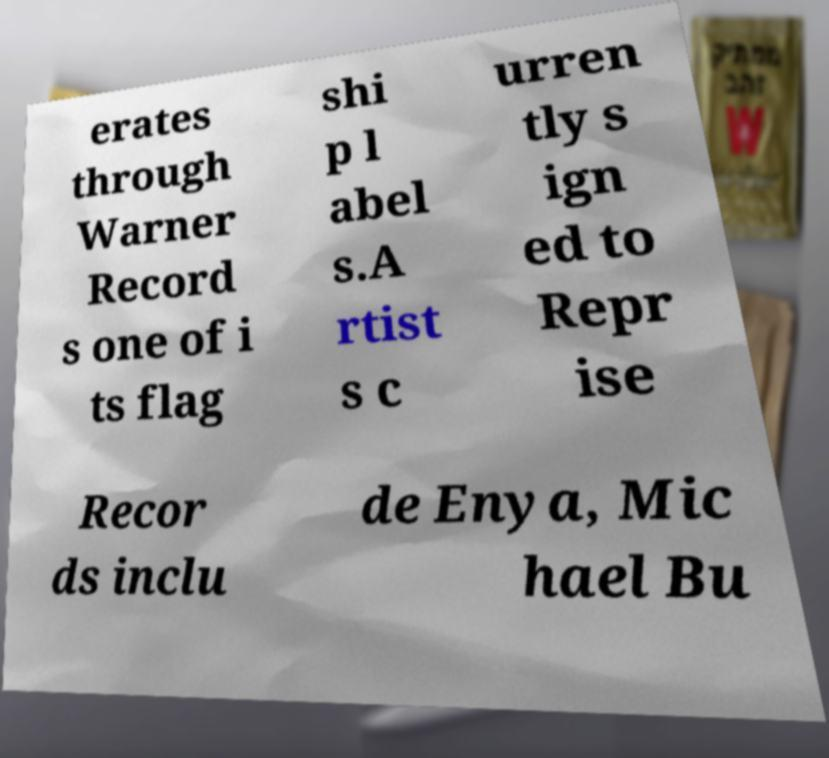Please read and relay the text visible in this image. What does it say? erates through Warner Record s one of i ts flag shi p l abel s.A rtist s c urren tly s ign ed to Repr ise Recor ds inclu de Enya, Mic hael Bu 